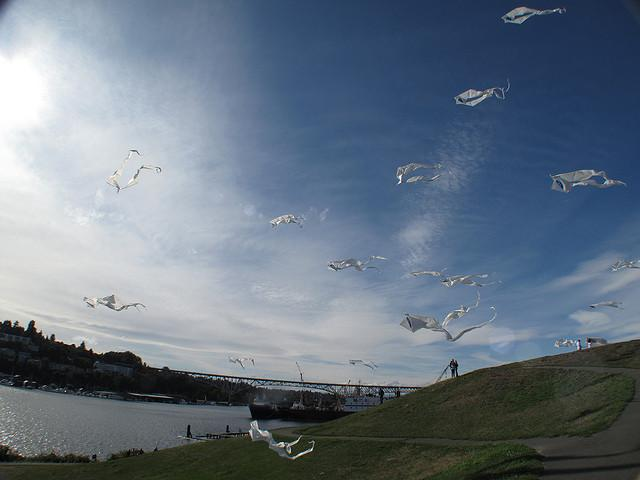How many kind of kite shapes available? one 